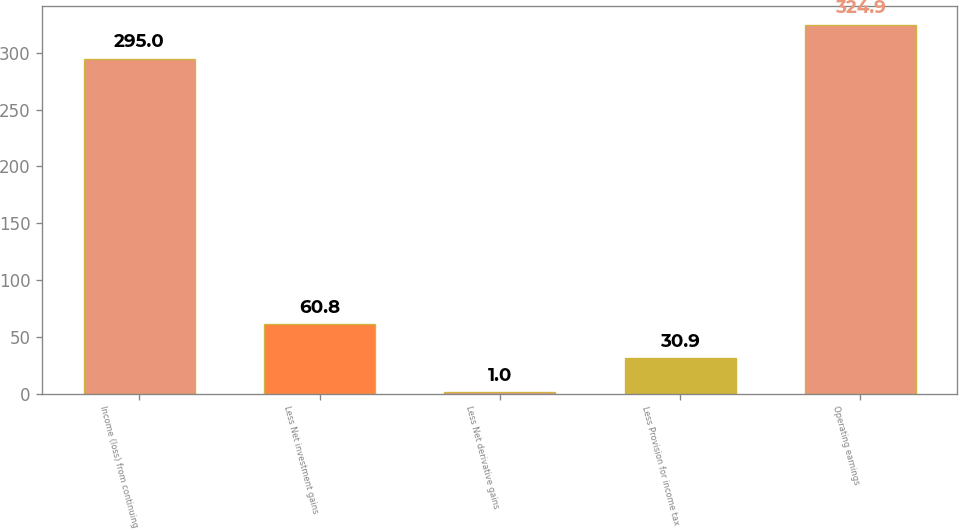Convert chart to OTSL. <chart><loc_0><loc_0><loc_500><loc_500><bar_chart><fcel>Income (loss) from continuing<fcel>Less Net investment gains<fcel>Less Net derivative gains<fcel>Less Provision for income tax<fcel>Operating earnings<nl><fcel>295<fcel>60.8<fcel>1<fcel>30.9<fcel>324.9<nl></chart> 